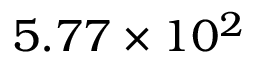<formula> <loc_0><loc_0><loc_500><loc_500>5 . 7 7 \times 1 0 ^ { 2 }</formula> 